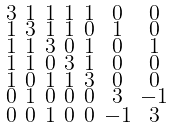<formula> <loc_0><loc_0><loc_500><loc_500>\begin{smallmatrix} 3 & 1 & 1 & 1 & 1 & 0 & 0 \\ 1 & 3 & 1 & 1 & 0 & 1 & 0 \\ 1 & 1 & 3 & 0 & 1 & 0 & 1 \\ 1 & 1 & 0 & 3 & 1 & 0 & 0 \\ 1 & 0 & 1 & 1 & 3 & 0 & 0 \\ 0 & 1 & 0 & 0 & 0 & 3 & - 1 \\ 0 & 0 & 1 & 0 & 0 & - 1 & 3 \end{smallmatrix}</formula> 